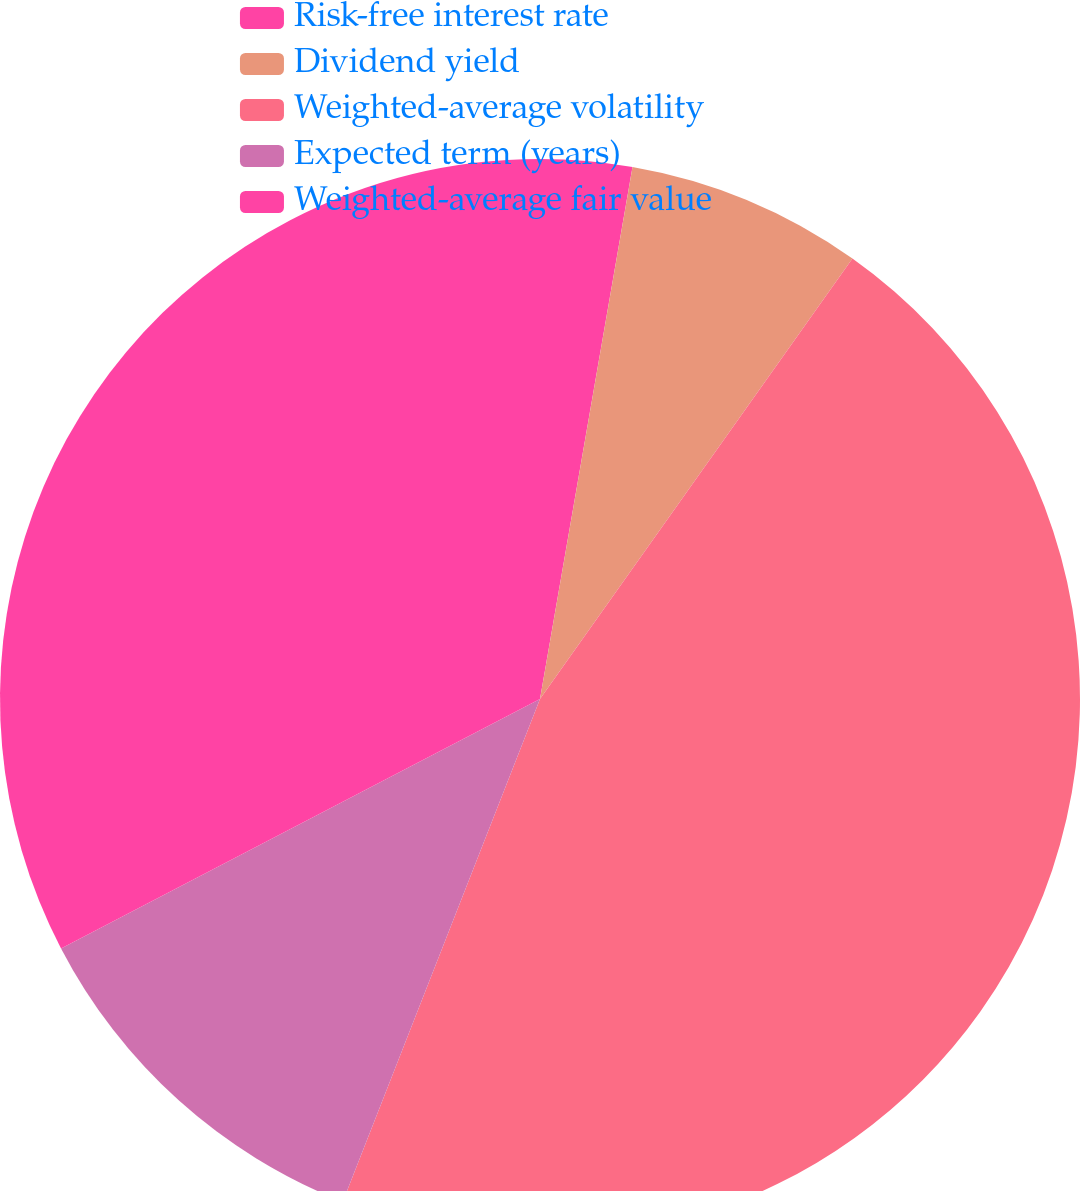Convert chart to OTSL. <chart><loc_0><loc_0><loc_500><loc_500><pie_chart><fcel>Risk-free interest rate<fcel>Dividend yield<fcel>Weighted-average volatility<fcel>Expected term (years)<fcel>Weighted-average fair value<nl><fcel>2.74%<fcel>7.08%<fcel>46.13%<fcel>11.41%<fcel>32.64%<nl></chart> 